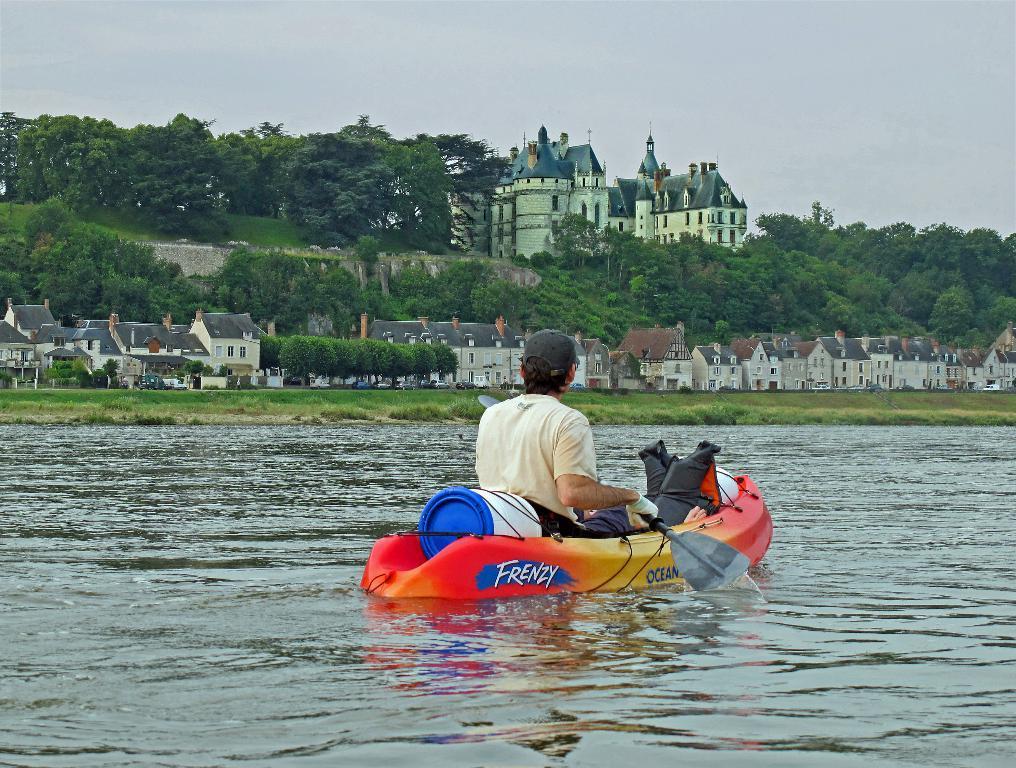In one or two sentences, can you explain what this image depicts? As we can see in the image there is water, a man sitting on fuel boat, houses, buildings, trees and sky. 